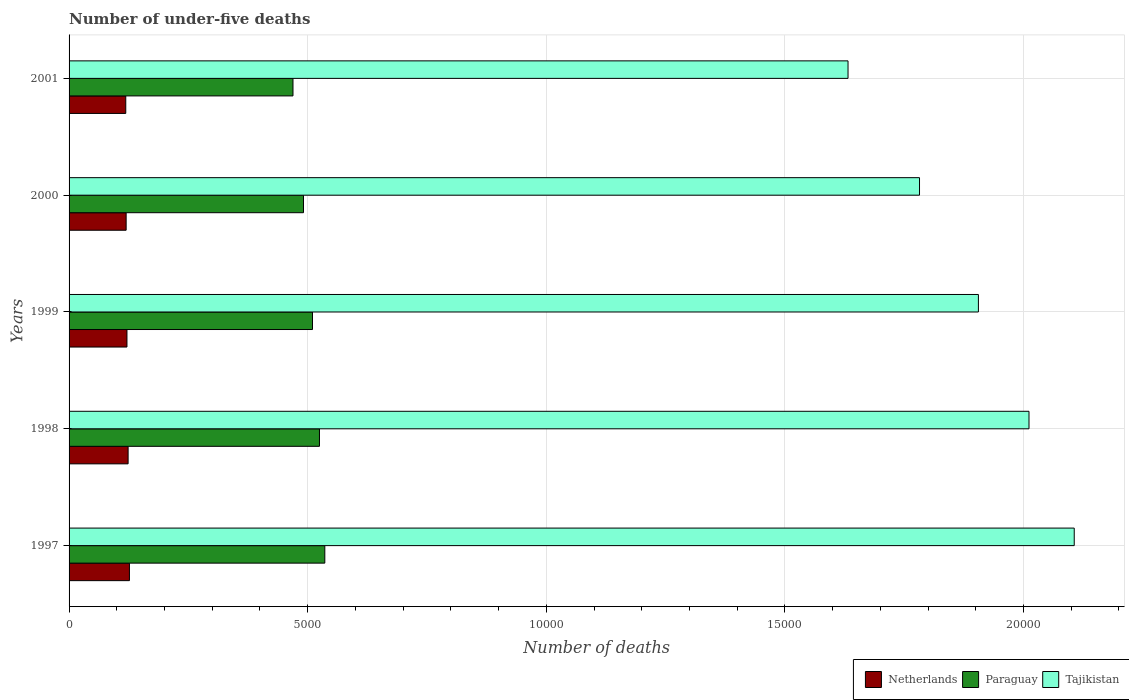How many different coloured bars are there?
Offer a very short reply. 3. How many bars are there on the 3rd tick from the top?
Give a very brief answer. 3. How many bars are there on the 2nd tick from the bottom?
Offer a very short reply. 3. In how many cases, is the number of bars for a given year not equal to the number of legend labels?
Your response must be concise. 0. What is the number of under-five deaths in Netherlands in 1997?
Your answer should be compact. 1265. Across all years, what is the maximum number of under-five deaths in Netherlands?
Your answer should be compact. 1265. Across all years, what is the minimum number of under-five deaths in Tajikistan?
Your answer should be very brief. 1.63e+04. In which year was the number of under-five deaths in Paraguay minimum?
Offer a terse response. 2001. What is the total number of under-five deaths in Tajikistan in the graph?
Keep it short and to the point. 9.44e+04. What is the difference between the number of under-five deaths in Tajikistan in 1997 and that in 1999?
Provide a short and direct response. 2008. What is the difference between the number of under-five deaths in Paraguay in 1997 and the number of under-five deaths in Netherlands in 1998?
Provide a short and direct response. 4122. What is the average number of under-five deaths in Tajikistan per year?
Ensure brevity in your answer.  1.89e+04. In the year 2001, what is the difference between the number of under-five deaths in Tajikistan and number of under-five deaths in Paraguay?
Keep it short and to the point. 1.16e+04. What is the ratio of the number of under-five deaths in Netherlands in 2000 to that in 2001?
Provide a short and direct response. 1.01. Is the number of under-five deaths in Tajikistan in 1997 less than that in 2000?
Provide a short and direct response. No. What is the difference between the highest and the lowest number of under-five deaths in Paraguay?
Provide a succinct answer. 667. In how many years, is the number of under-five deaths in Netherlands greater than the average number of under-five deaths in Netherlands taken over all years?
Offer a very short reply. 2. Is the sum of the number of under-five deaths in Paraguay in 1999 and 2000 greater than the maximum number of under-five deaths in Tajikistan across all years?
Provide a succinct answer. No. What does the 3rd bar from the bottom in 1999 represents?
Ensure brevity in your answer.  Tajikistan. Are all the bars in the graph horizontal?
Offer a terse response. Yes. How many years are there in the graph?
Your answer should be very brief. 5. Does the graph contain any zero values?
Provide a short and direct response. No. How are the legend labels stacked?
Your response must be concise. Horizontal. What is the title of the graph?
Your answer should be compact. Number of under-five deaths. Does "Suriname" appear as one of the legend labels in the graph?
Keep it short and to the point. No. What is the label or title of the X-axis?
Offer a terse response. Number of deaths. What is the Number of deaths in Netherlands in 1997?
Ensure brevity in your answer.  1265. What is the Number of deaths of Paraguay in 1997?
Provide a short and direct response. 5359. What is the Number of deaths of Tajikistan in 1997?
Ensure brevity in your answer.  2.11e+04. What is the Number of deaths in Netherlands in 1998?
Provide a succinct answer. 1237. What is the Number of deaths in Paraguay in 1998?
Provide a succinct answer. 5247. What is the Number of deaths in Tajikistan in 1998?
Ensure brevity in your answer.  2.01e+04. What is the Number of deaths of Netherlands in 1999?
Give a very brief answer. 1213. What is the Number of deaths of Paraguay in 1999?
Your response must be concise. 5101. What is the Number of deaths in Tajikistan in 1999?
Provide a succinct answer. 1.91e+04. What is the Number of deaths of Netherlands in 2000?
Provide a short and direct response. 1196. What is the Number of deaths of Paraguay in 2000?
Give a very brief answer. 4912. What is the Number of deaths of Tajikistan in 2000?
Your answer should be very brief. 1.78e+04. What is the Number of deaths in Netherlands in 2001?
Your answer should be compact. 1188. What is the Number of deaths of Paraguay in 2001?
Make the answer very short. 4692. What is the Number of deaths of Tajikistan in 2001?
Provide a succinct answer. 1.63e+04. Across all years, what is the maximum Number of deaths in Netherlands?
Your answer should be very brief. 1265. Across all years, what is the maximum Number of deaths of Paraguay?
Ensure brevity in your answer.  5359. Across all years, what is the maximum Number of deaths in Tajikistan?
Your response must be concise. 2.11e+04. Across all years, what is the minimum Number of deaths of Netherlands?
Provide a succinct answer. 1188. Across all years, what is the minimum Number of deaths of Paraguay?
Make the answer very short. 4692. Across all years, what is the minimum Number of deaths of Tajikistan?
Offer a terse response. 1.63e+04. What is the total Number of deaths in Netherlands in the graph?
Provide a succinct answer. 6099. What is the total Number of deaths in Paraguay in the graph?
Your answer should be very brief. 2.53e+04. What is the total Number of deaths of Tajikistan in the graph?
Your answer should be compact. 9.44e+04. What is the difference between the Number of deaths of Paraguay in 1997 and that in 1998?
Keep it short and to the point. 112. What is the difference between the Number of deaths in Tajikistan in 1997 and that in 1998?
Keep it short and to the point. 948. What is the difference between the Number of deaths in Netherlands in 1997 and that in 1999?
Provide a short and direct response. 52. What is the difference between the Number of deaths in Paraguay in 1997 and that in 1999?
Make the answer very short. 258. What is the difference between the Number of deaths of Tajikistan in 1997 and that in 1999?
Your response must be concise. 2008. What is the difference between the Number of deaths of Paraguay in 1997 and that in 2000?
Your answer should be compact. 447. What is the difference between the Number of deaths of Tajikistan in 1997 and that in 2000?
Provide a succinct answer. 3242. What is the difference between the Number of deaths in Paraguay in 1997 and that in 2001?
Your response must be concise. 667. What is the difference between the Number of deaths of Tajikistan in 1997 and that in 2001?
Keep it short and to the point. 4740. What is the difference between the Number of deaths of Paraguay in 1998 and that in 1999?
Your response must be concise. 146. What is the difference between the Number of deaths of Tajikistan in 1998 and that in 1999?
Keep it short and to the point. 1060. What is the difference between the Number of deaths in Paraguay in 1998 and that in 2000?
Provide a short and direct response. 335. What is the difference between the Number of deaths of Tajikistan in 1998 and that in 2000?
Provide a succinct answer. 2294. What is the difference between the Number of deaths in Netherlands in 1998 and that in 2001?
Ensure brevity in your answer.  49. What is the difference between the Number of deaths in Paraguay in 1998 and that in 2001?
Your answer should be compact. 555. What is the difference between the Number of deaths of Tajikistan in 1998 and that in 2001?
Provide a succinct answer. 3792. What is the difference between the Number of deaths in Netherlands in 1999 and that in 2000?
Give a very brief answer. 17. What is the difference between the Number of deaths of Paraguay in 1999 and that in 2000?
Ensure brevity in your answer.  189. What is the difference between the Number of deaths of Tajikistan in 1999 and that in 2000?
Ensure brevity in your answer.  1234. What is the difference between the Number of deaths of Paraguay in 1999 and that in 2001?
Your answer should be compact. 409. What is the difference between the Number of deaths of Tajikistan in 1999 and that in 2001?
Your answer should be compact. 2732. What is the difference between the Number of deaths of Netherlands in 2000 and that in 2001?
Offer a very short reply. 8. What is the difference between the Number of deaths of Paraguay in 2000 and that in 2001?
Your response must be concise. 220. What is the difference between the Number of deaths in Tajikistan in 2000 and that in 2001?
Keep it short and to the point. 1498. What is the difference between the Number of deaths in Netherlands in 1997 and the Number of deaths in Paraguay in 1998?
Offer a very short reply. -3982. What is the difference between the Number of deaths in Netherlands in 1997 and the Number of deaths in Tajikistan in 1998?
Keep it short and to the point. -1.88e+04. What is the difference between the Number of deaths of Paraguay in 1997 and the Number of deaths of Tajikistan in 1998?
Your answer should be very brief. -1.48e+04. What is the difference between the Number of deaths of Netherlands in 1997 and the Number of deaths of Paraguay in 1999?
Ensure brevity in your answer.  -3836. What is the difference between the Number of deaths of Netherlands in 1997 and the Number of deaths of Tajikistan in 1999?
Ensure brevity in your answer.  -1.78e+04. What is the difference between the Number of deaths of Paraguay in 1997 and the Number of deaths of Tajikistan in 1999?
Keep it short and to the point. -1.37e+04. What is the difference between the Number of deaths in Netherlands in 1997 and the Number of deaths in Paraguay in 2000?
Ensure brevity in your answer.  -3647. What is the difference between the Number of deaths of Netherlands in 1997 and the Number of deaths of Tajikistan in 2000?
Offer a very short reply. -1.66e+04. What is the difference between the Number of deaths in Paraguay in 1997 and the Number of deaths in Tajikistan in 2000?
Make the answer very short. -1.25e+04. What is the difference between the Number of deaths of Netherlands in 1997 and the Number of deaths of Paraguay in 2001?
Ensure brevity in your answer.  -3427. What is the difference between the Number of deaths in Netherlands in 1997 and the Number of deaths in Tajikistan in 2001?
Keep it short and to the point. -1.51e+04. What is the difference between the Number of deaths in Paraguay in 1997 and the Number of deaths in Tajikistan in 2001?
Ensure brevity in your answer.  -1.10e+04. What is the difference between the Number of deaths of Netherlands in 1998 and the Number of deaths of Paraguay in 1999?
Your answer should be compact. -3864. What is the difference between the Number of deaths of Netherlands in 1998 and the Number of deaths of Tajikistan in 1999?
Ensure brevity in your answer.  -1.78e+04. What is the difference between the Number of deaths of Paraguay in 1998 and the Number of deaths of Tajikistan in 1999?
Make the answer very short. -1.38e+04. What is the difference between the Number of deaths in Netherlands in 1998 and the Number of deaths in Paraguay in 2000?
Offer a very short reply. -3675. What is the difference between the Number of deaths in Netherlands in 1998 and the Number of deaths in Tajikistan in 2000?
Ensure brevity in your answer.  -1.66e+04. What is the difference between the Number of deaths in Paraguay in 1998 and the Number of deaths in Tajikistan in 2000?
Provide a succinct answer. -1.26e+04. What is the difference between the Number of deaths of Netherlands in 1998 and the Number of deaths of Paraguay in 2001?
Provide a short and direct response. -3455. What is the difference between the Number of deaths of Netherlands in 1998 and the Number of deaths of Tajikistan in 2001?
Offer a terse response. -1.51e+04. What is the difference between the Number of deaths in Paraguay in 1998 and the Number of deaths in Tajikistan in 2001?
Provide a succinct answer. -1.11e+04. What is the difference between the Number of deaths in Netherlands in 1999 and the Number of deaths in Paraguay in 2000?
Ensure brevity in your answer.  -3699. What is the difference between the Number of deaths in Netherlands in 1999 and the Number of deaths in Tajikistan in 2000?
Offer a very short reply. -1.66e+04. What is the difference between the Number of deaths in Paraguay in 1999 and the Number of deaths in Tajikistan in 2000?
Give a very brief answer. -1.27e+04. What is the difference between the Number of deaths of Netherlands in 1999 and the Number of deaths of Paraguay in 2001?
Keep it short and to the point. -3479. What is the difference between the Number of deaths in Netherlands in 1999 and the Number of deaths in Tajikistan in 2001?
Ensure brevity in your answer.  -1.51e+04. What is the difference between the Number of deaths in Paraguay in 1999 and the Number of deaths in Tajikistan in 2001?
Offer a terse response. -1.12e+04. What is the difference between the Number of deaths in Netherlands in 2000 and the Number of deaths in Paraguay in 2001?
Give a very brief answer. -3496. What is the difference between the Number of deaths of Netherlands in 2000 and the Number of deaths of Tajikistan in 2001?
Keep it short and to the point. -1.51e+04. What is the difference between the Number of deaths in Paraguay in 2000 and the Number of deaths in Tajikistan in 2001?
Your answer should be compact. -1.14e+04. What is the average Number of deaths of Netherlands per year?
Make the answer very short. 1219.8. What is the average Number of deaths in Paraguay per year?
Your answer should be compact. 5062.2. What is the average Number of deaths in Tajikistan per year?
Offer a very short reply. 1.89e+04. In the year 1997, what is the difference between the Number of deaths in Netherlands and Number of deaths in Paraguay?
Your response must be concise. -4094. In the year 1997, what is the difference between the Number of deaths of Netherlands and Number of deaths of Tajikistan?
Your response must be concise. -1.98e+04. In the year 1997, what is the difference between the Number of deaths in Paraguay and Number of deaths in Tajikistan?
Your response must be concise. -1.57e+04. In the year 1998, what is the difference between the Number of deaths in Netherlands and Number of deaths in Paraguay?
Your answer should be compact. -4010. In the year 1998, what is the difference between the Number of deaths in Netherlands and Number of deaths in Tajikistan?
Ensure brevity in your answer.  -1.89e+04. In the year 1998, what is the difference between the Number of deaths in Paraguay and Number of deaths in Tajikistan?
Offer a very short reply. -1.49e+04. In the year 1999, what is the difference between the Number of deaths of Netherlands and Number of deaths of Paraguay?
Keep it short and to the point. -3888. In the year 1999, what is the difference between the Number of deaths in Netherlands and Number of deaths in Tajikistan?
Provide a succinct answer. -1.78e+04. In the year 1999, what is the difference between the Number of deaths in Paraguay and Number of deaths in Tajikistan?
Your answer should be compact. -1.40e+04. In the year 2000, what is the difference between the Number of deaths of Netherlands and Number of deaths of Paraguay?
Keep it short and to the point. -3716. In the year 2000, what is the difference between the Number of deaths in Netherlands and Number of deaths in Tajikistan?
Keep it short and to the point. -1.66e+04. In the year 2000, what is the difference between the Number of deaths in Paraguay and Number of deaths in Tajikistan?
Your response must be concise. -1.29e+04. In the year 2001, what is the difference between the Number of deaths of Netherlands and Number of deaths of Paraguay?
Provide a succinct answer. -3504. In the year 2001, what is the difference between the Number of deaths in Netherlands and Number of deaths in Tajikistan?
Your answer should be very brief. -1.51e+04. In the year 2001, what is the difference between the Number of deaths in Paraguay and Number of deaths in Tajikistan?
Provide a short and direct response. -1.16e+04. What is the ratio of the Number of deaths in Netherlands in 1997 to that in 1998?
Give a very brief answer. 1.02. What is the ratio of the Number of deaths of Paraguay in 1997 to that in 1998?
Your answer should be compact. 1.02. What is the ratio of the Number of deaths in Tajikistan in 1997 to that in 1998?
Your answer should be compact. 1.05. What is the ratio of the Number of deaths in Netherlands in 1997 to that in 1999?
Provide a short and direct response. 1.04. What is the ratio of the Number of deaths in Paraguay in 1997 to that in 1999?
Give a very brief answer. 1.05. What is the ratio of the Number of deaths of Tajikistan in 1997 to that in 1999?
Provide a succinct answer. 1.11. What is the ratio of the Number of deaths of Netherlands in 1997 to that in 2000?
Give a very brief answer. 1.06. What is the ratio of the Number of deaths of Paraguay in 1997 to that in 2000?
Offer a terse response. 1.09. What is the ratio of the Number of deaths in Tajikistan in 1997 to that in 2000?
Offer a terse response. 1.18. What is the ratio of the Number of deaths of Netherlands in 1997 to that in 2001?
Offer a very short reply. 1.06. What is the ratio of the Number of deaths in Paraguay in 1997 to that in 2001?
Offer a very short reply. 1.14. What is the ratio of the Number of deaths in Tajikistan in 1997 to that in 2001?
Ensure brevity in your answer.  1.29. What is the ratio of the Number of deaths of Netherlands in 1998 to that in 1999?
Offer a terse response. 1.02. What is the ratio of the Number of deaths of Paraguay in 1998 to that in 1999?
Offer a very short reply. 1.03. What is the ratio of the Number of deaths in Tajikistan in 1998 to that in 1999?
Offer a terse response. 1.06. What is the ratio of the Number of deaths of Netherlands in 1998 to that in 2000?
Keep it short and to the point. 1.03. What is the ratio of the Number of deaths of Paraguay in 1998 to that in 2000?
Offer a very short reply. 1.07. What is the ratio of the Number of deaths of Tajikistan in 1998 to that in 2000?
Your answer should be compact. 1.13. What is the ratio of the Number of deaths in Netherlands in 1998 to that in 2001?
Your answer should be very brief. 1.04. What is the ratio of the Number of deaths of Paraguay in 1998 to that in 2001?
Provide a succinct answer. 1.12. What is the ratio of the Number of deaths of Tajikistan in 1998 to that in 2001?
Provide a succinct answer. 1.23. What is the ratio of the Number of deaths of Netherlands in 1999 to that in 2000?
Ensure brevity in your answer.  1.01. What is the ratio of the Number of deaths in Tajikistan in 1999 to that in 2000?
Offer a terse response. 1.07. What is the ratio of the Number of deaths of Netherlands in 1999 to that in 2001?
Provide a short and direct response. 1.02. What is the ratio of the Number of deaths in Paraguay in 1999 to that in 2001?
Your response must be concise. 1.09. What is the ratio of the Number of deaths in Tajikistan in 1999 to that in 2001?
Your response must be concise. 1.17. What is the ratio of the Number of deaths in Paraguay in 2000 to that in 2001?
Your answer should be very brief. 1.05. What is the ratio of the Number of deaths of Tajikistan in 2000 to that in 2001?
Provide a succinct answer. 1.09. What is the difference between the highest and the second highest Number of deaths in Paraguay?
Provide a succinct answer. 112. What is the difference between the highest and the second highest Number of deaths of Tajikistan?
Offer a terse response. 948. What is the difference between the highest and the lowest Number of deaths in Paraguay?
Offer a very short reply. 667. What is the difference between the highest and the lowest Number of deaths of Tajikistan?
Your answer should be compact. 4740. 